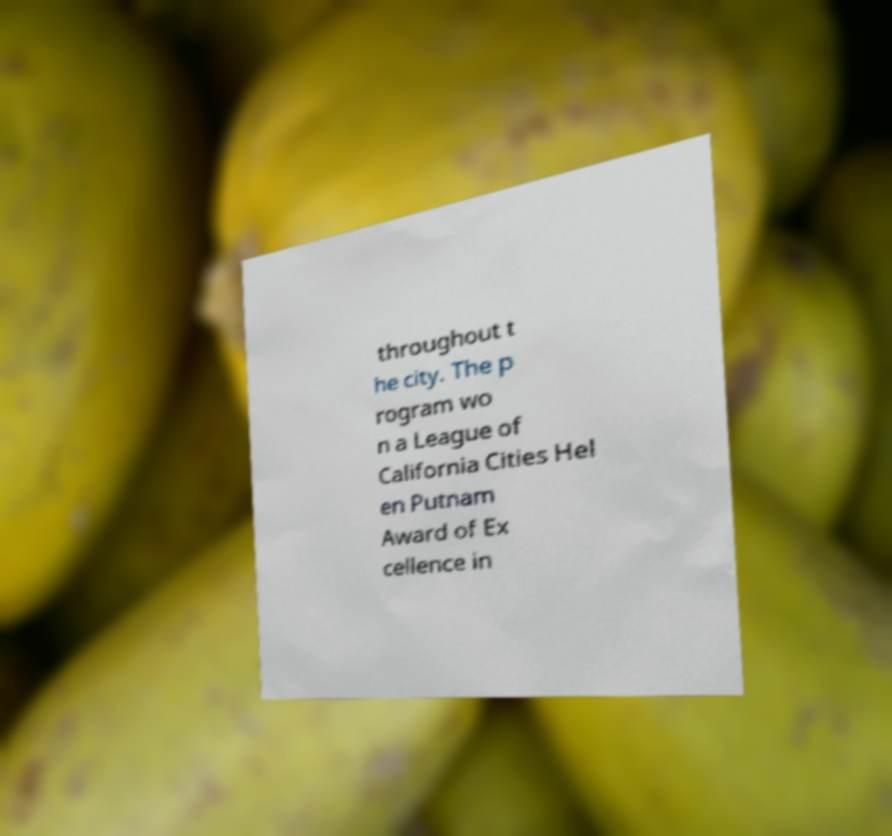Could you assist in decoding the text presented in this image and type it out clearly? throughout t he city. The p rogram wo n a League of California Cities Hel en Putnam Award of Ex cellence in 